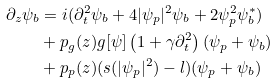Convert formula to latex. <formula><loc_0><loc_0><loc_500><loc_500>\partial _ { z } \psi _ { b } & = i ( \partial _ { t } ^ { 2 } \psi _ { b } + 4 | \psi _ { p } | ^ { 2 } \psi _ { b } + 2 \psi _ { p } ^ { 2 } \psi _ { b } ^ { * } ) \\ & + p _ { g } ( z ) g [ \psi ] \left ( 1 + \gamma \partial _ { t } ^ { 2 } \right ) ( \psi _ { p } + \psi _ { b } ) \\ & + p _ { p } ( z ) ( s ( | \psi _ { p } | ^ { 2 } ) - l ) ( \psi _ { p } + \psi _ { b } )</formula> 